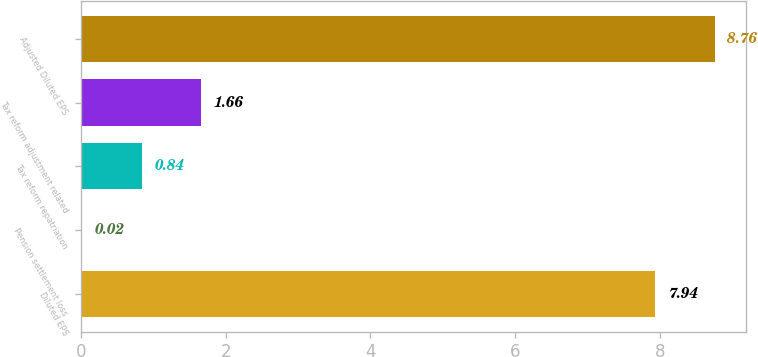<chart> <loc_0><loc_0><loc_500><loc_500><bar_chart><fcel>Diluted EPS<fcel>Pension settlement loss<fcel>Tax reform repatriation<fcel>Tax reform adjustment related<fcel>Adjusted Diluted EPS<nl><fcel>7.94<fcel>0.02<fcel>0.84<fcel>1.66<fcel>8.76<nl></chart> 